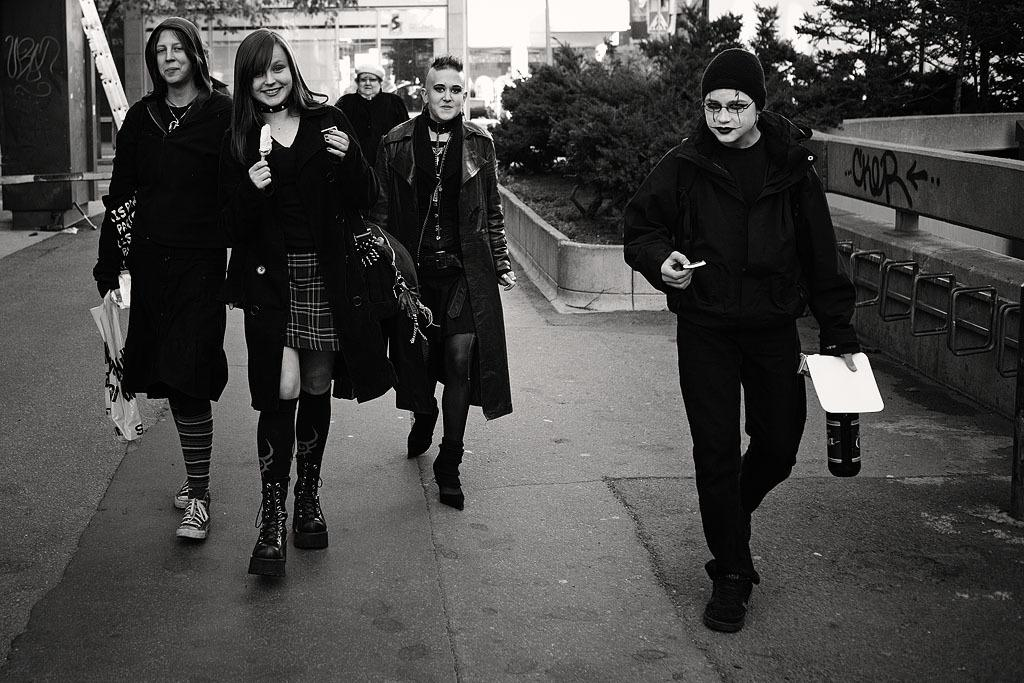What is the color scheme of the image? The image is black and white. What can be seen happening on the road in the image? There are people walking on the road in the image. What type of natural scenery is visible in the background of the image? There are trees in the background of the image. What type of man-made structures can be seen in the background of the image? There are buildings in the background of the image. What is the income of the manager in the image? There is no mention of a manager or income in the image, as it only shows people walking on the road and the background scenery. 